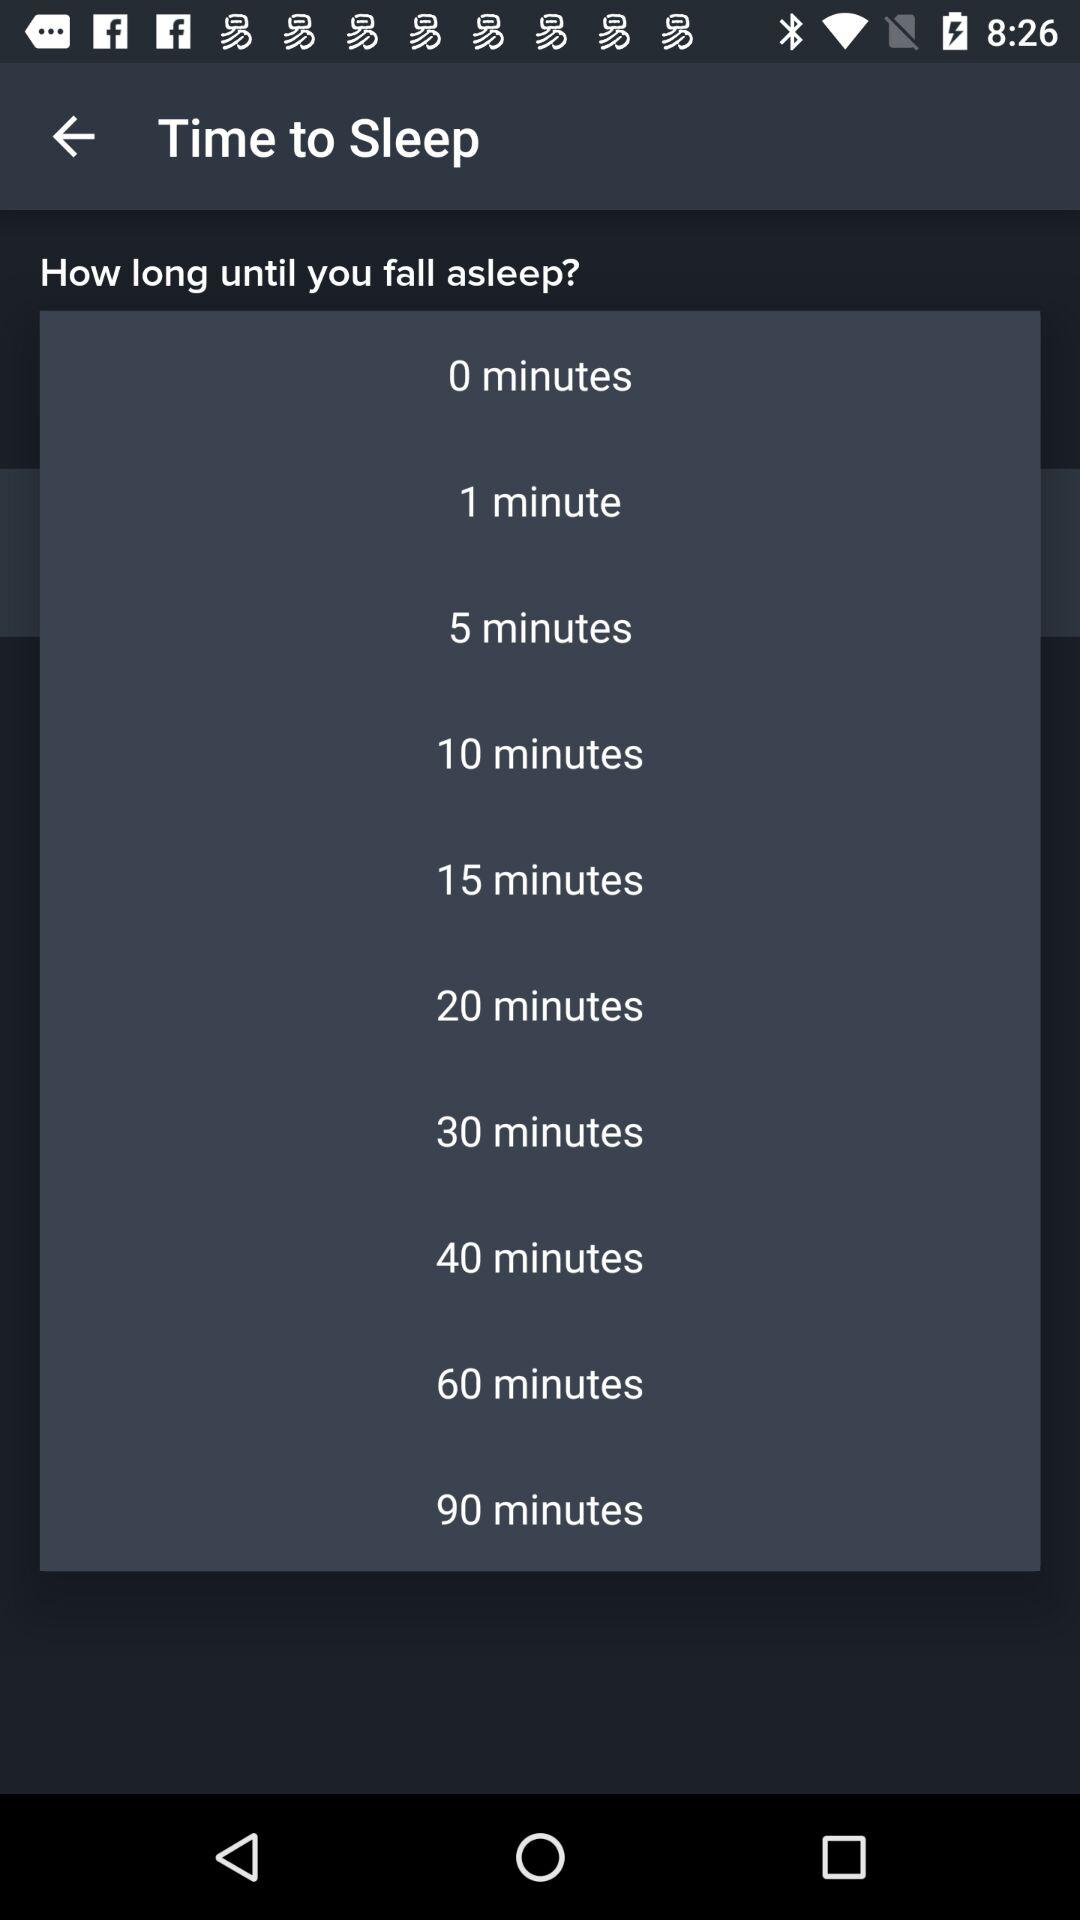How many minutes is the longest time until I can fall asleep?
Answer the question using a single word or phrase. 90 minutes 